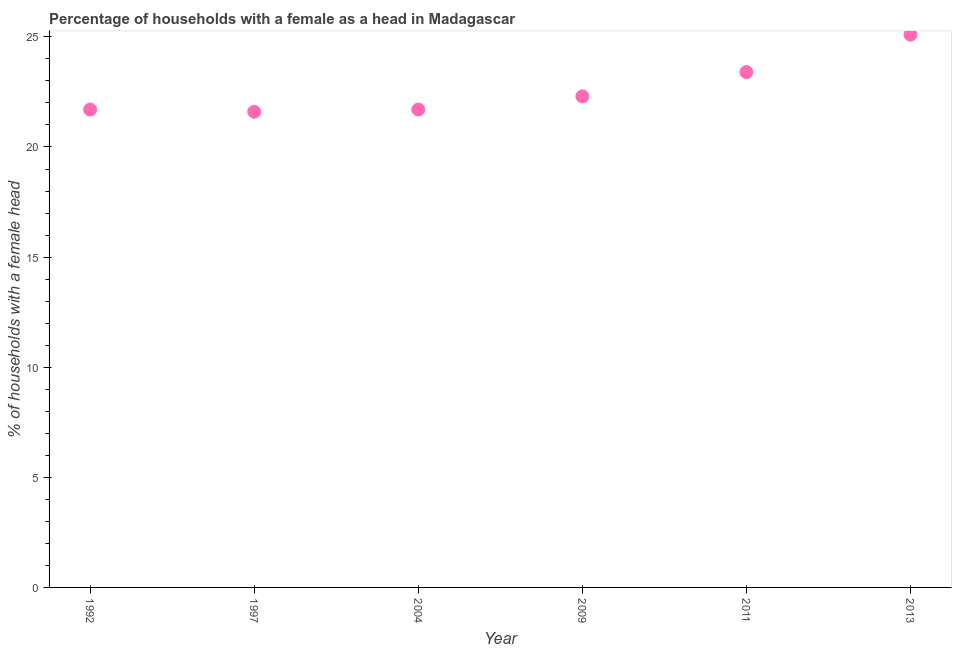What is the number of female supervised households in 1992?
Offer a very short reply. 21.7. Across all years, what is the maximum number of female supervised households?
Ensure brevity in your answer.  25.1. Across all years, what is the minimum number of female supervised households?
Provide a short and direct response. 21.6. In which year was the number of female supervised households minimum?
Your answer should be very brief. 1997. What is the sum of the number of female supervised households?
Offer a very short reply. 135.8. What is the difference between the number of female supervised households in 1992 and 2013?
Your answer should be compact. -3.4. What is the average number of female supervised households per year?
Provide a succinct answer. 22.63. What is the ratio of the number of female supervised households in 1997 to that in 2011?
Make the answer very short. 0.92. What is the difference between the highest and the second highest number of female supervised households?
Your answer should be very brief. 1.7. Is the sum of the number of female supervised households in 2004 and 2009 greater than the maximum number of female supervised households across all years?
Your response must be concise. Yes. Does the number of female supervised households monotonically increase over the years?
Give a very brief answer. No. How many dotlines are there?
Offer a very short reply. 1. What is the difference between two consecutive major ticks on the Y-axis?
Your response must be concise. 5. Are the values on the major ticks of Y-axis written in scientific E-notation?
Ensure brevity in your answer.  No. Does the graph contain any zero values?
Make the answer very short. No. Does the graph contain grids?
Offer a terse response. No. What is the title of the graph?
Offer a terse response. Percentage of households with a female as a head in Madagascar. What is the label or title of the X-axis?
Provide a short and direct response. Year. What is the label or title of the Y-axis?
Provide a short and direct response. % of households with a female head. What is the % of households with a female head in 1992?
Ensure brevity in your answer.  21.7. What is the % of households with a female head in 1997?
Give a very brief answer. 21.6. What is the % of households with a female head in 2004?
Offer a very short reply. 21.7. What is the % of households with a female head in 2009?
Your answer should be very brief. 22.3. What is the % of households with a female head in 2011?
Give a very brief answer. 23.4. What is the % of households with a female head in 2013?
Your response must be concise. 25.1. What is the difference between the % of households with a female head in 1992 and 1997?
Offer a very short reply. 0.1. What is the difference between the % of households with a female head in 1992 and 2009?
Provide a succinct answer. -0.6. What is the difference between the % of households with a female head in 1997 and 2004?
Your response must be concise. -0.1. What is the difference between the % of households with a female head in 1997 and 2011?
Ensure brevity in your answer.  -1.8. What is the difference between the % of households with a female head in 1997 and 2013?
Ensure brevity in your answer.  -3.5. What is the difference between the % of households with a female head in 2004 and 2011?
Give a very brief answer. -1.7. What is the difference between the % of households with a female head in 2009 and 2011?
Provide a short and direct response. -1.1. What is the difference between the % of households with a female head in 2009 and 2013?
Ensure brevity in your answer.  -2.8. What is the ratio of the % of households with a female head in 1992 to that in 2011?
Your answer should be compact. 0.93. What is the ratio of the % of households with a female head in 1992 to that in 2013?
Provide a succinct answer. 0.86. What is the ratio of the % of households with a female head in 1997 to that in 2004?
Your response must be concise. 0.99. What is the ratio of the % of households with a female head in 1997 to that in 2011?
Ensure brevity in your answer.  0.92. What is the ratio of the % of households with a female head in 1997 to that in 2013?
Provide a succinct answer. 0.86. What is the ratio of the % of households with a female head in 2004 to that in 2011?
Ensure brevity in your answer.  0.93. What is the ratio of the % of households with a female head in 2004 to that in 2013?
Give a very brief answer. 0.86. What is the ratio of the % of households with a female head in 2009 to that in 2011?
Your answer should be very brief. 0.95. What is the ratio of the % of households with a female head in 2009 to that in 2013?
Keep it short and to the point. 0.89. What is the ratio of the % of households with a female head in 2011 to that in 2013?
Offer a very short reply. 0.93. 